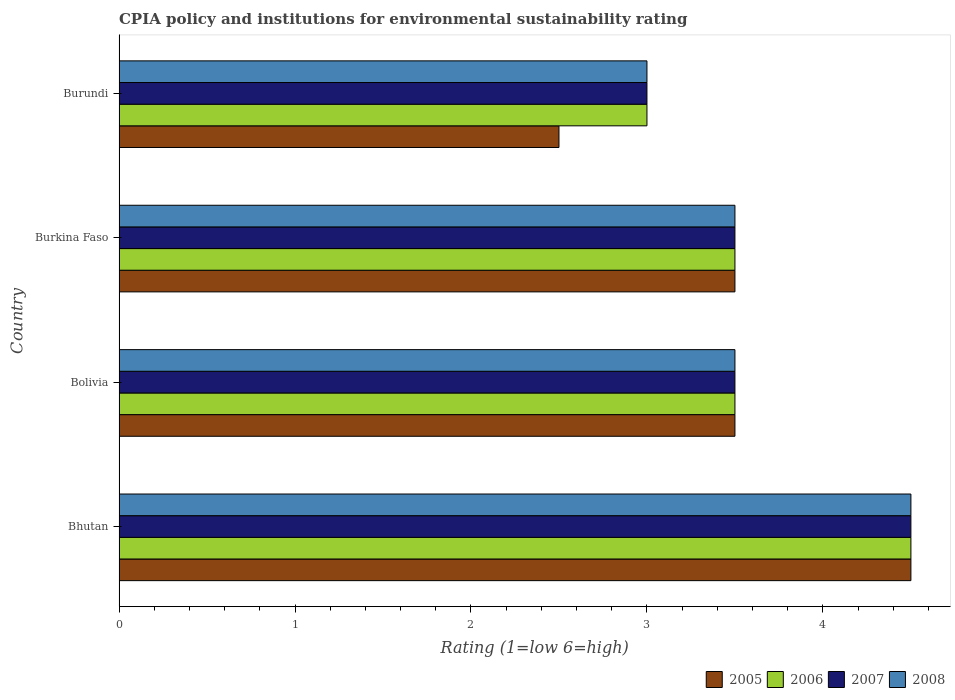How many different coloured bars are there?
Give a very brief answer. 4. How many groups of bars are there?
Your answer should be very brief. 4. How many bars are there on the 2nd tick from the bottom?
Provide a succinct answer. 4. In how many cases, is the number of bars for a given country not equal to the number of legend labels?
Offer a very short reply. 0. What is the CPIA rating in 2005 in Bolivia?
Make the answer very short. 3.5. Across all countries, what is the maximum CPIA rating in 2007?
Give a very brief answer. 4.5. Across all countries, what is the minimum CPIA rating in 2008?
Provide a succinct answer. 3. In which country was the CPIA rating in 2005 maximum?
Offer a very short reply. Bhutan. In which country was the CPIA rating in 2007 minimum?
Keep it short and to the point. Burundi. What is the total CPIA rating in 2008 in the graph?
Give a very brief answer. 14.5. What is the difference between the CPIA rating in 2005 in Bhutan and that in Burundi?
Keep it short and to the point. 2. What is the average CPIA rating in 2007 per country?
Offer a terse response. 3.62. In how many countries, is the CPIA rating in 2008 greater than 2.8 ?
Keep it short and to the point. 4. What is the ratio of the CPIA rating in 2006 in Bolivia to that in Burundi?
Keep it short and to the point. 1.17. Is the CPIA rating in 2005 in Bhutan less than that in Burkina Faso?
Make the answer very short. No. Is the difference between the CPIA rating in 2005 in Bhutan and Burundi greater than the difference between the CPIA rating in 2007 in Bhutan and Burundi?
Keep it short and to the point. Yes. What is the difference between the highest and the lowest CPIA rating in 2007?
Provide a succinct answer. 1.5. In how many countries, is the CPIA rating in 2008 greater than the average CPIA rating in 2008 taken over all countries?
Your answer should be compact. 1. Is it the case that in every country, the sum of the CPIA rating in 2005 and CPIA rating in 2008 is greater than the sum of CPIA rating in 2007 and CPIA rating in 2006?
Offer a terse response. No. How many bars are there?
Give a very brief answer. 16. What is the difference between two consecutive major ticks on the X-axis?
Ensure brevity in your answer.  1. Are the values on the major ticks of X-axis written in scientific E-notation?
Give a very brief answer. No. Does the graph contain any zero values?
Offer a terse response. No. How many legend labels are there?
Your answer should be very brief. 4. What is the title of the graph?
Keep it short and to the point. CPIA policy and institutions for environmental sustainability rating. What is the label or title of the X-axis?
Provide a succinct answer. Rating (1=low 6=high). What is the Rating (1=low 6=high) of 2005 in Bhutan?
Offer a very short reply. 4.5. What is the Rating (1=low 6=high) in 2006 in Bhutan?
Your answer should be compact. 4.5. What is the Rating (1=low 6=high) of 2007 in Bhutan?
Your answer should be compact. 4.5. What is the Rating (1=low 6=high) in 2005 in Bolivia?
Your answer should be compact. 3.5. What is the Rating (1=low 6=high) of 2006 in Bolivia?
Offer a very short reply. 3.5. What is the Rating (1=low 6=high) of 2007 in Bolivia?
Offer a very short reply. 3.5. What is the Rating (1=low 6=high) of 2006 in Burkina Faso?
Keep it short and to the point. 3.5. What is the Rating (1=low 6=high) in 2006 in Burundi?
Ensure brevity in your answer.  3. What is the Rating (1=low 6=high) in 2007 in Burundi?
Your response must be concise. 3. What is the Rating (1=low 6=high) in 2008 in Burundi?
Offer a terse response. 3. Across all countries, what is the maximum Rating (1=low 6=high) of 2007?
Your answer should be very brief. 4.5. Across all countries, what is the minimum Rating (1=low 6=high) in 2005?
Provide a succinct answer. 2.5. Across all countries, what is the minimum Rating (1=low 6=high) in 2006?
Your response must be concise. 3. What is the total Rating (1=low 6=high) of 2005 in the graph?
Keep it short and to the point. 14. What is the total Rating (1=low 6=high) in 2006 in the graph?
Ensure brevity in your answer.  14.5. What is the total Rating (1=low 6=high) of 2007 in the graph?
Give a very brief answer. 14.5. What is the total Rating (1=low 6=high) in 2008 in the graph?
Keep it short and to the point. 14.5. What is the difference between the Rating (1=low 6=high) of 2006 in Bhutan and that in Bolivia?
Keep it short and to the point. 1. What is the difference between the Rating (1=low 6=high) in 2007 in Bhutan and that in Bolivia?
Your answer should be very brief. 1. What is the difference between the Rating (1=low 6=high) in 2008 in Bhutan and that in Bolivia?
Your response must be concise. 1. What is the difference between the Rating (1=low 6=high) of 2005 in Bhutan and that in Burkina Faso?
Provide a short and direct response. 1. What is the difference between the Rating (1=low 6=high) of 2006 in Bhutan and that in Burkina Faso?
Keep it short and to the point. 1. What is the difference between the Rating (1=low 6=high) of 2008 in Bhutan and that in Burkina Faso?
Your answer should be very brief. 1. What is the difference between the Rating (1=low 6=high) of 2005 in Bolivia and that in Burkina Faso?
Provide a short and direct response. 0. What is the difference between the Rating (1=low 6=high) in 2008 in Bolivia and that in Burkina Faso?
Offer a very short reply. 0. What is the difference between the Rating (1=low 6=high) in 2005 in Bolivia and that in Burundi?
Ensure brevity in your answer.  1. What is the difference between the Rating (1=low 6=high) of 2007 in Bolivia and that in Burundi?
Keep it short and to the point. 0.5. What is the difference between the Rating (1=low 6=high) of 2008 in Burkina Faso and that in Burundi?
Keep it short and to the point. 0.5. What is the difference between the Rating (1=low 6=high) in 2005 in Bhutan and the Rating (1=low 6=high) in 2006 in Bolivia?
Your answer should be compact. 1. What is the difference between the Rating (1=low 6=high) in 2006 in Bhutan and the Rating (1=low 6=high) in 2007 in Bolivia?
Provide a succinct answer. 1. What is the difference between the Rating (1=low 6=high) of 2007 in Bhutan and the Rating (1=low 6=high) of 2008 in Bolivia?
Offer a very short reply. 1. What is the difference between the Rating (1=low 6=high) in 2005 in Bhutan and the Rating (1=low 6=high) in 2006 in Burkina Faso?
Your answer should be very brief. 1. What is the difference between the Rating (1=low 6=high) of 2005 in Bhutan and the Rating (1=low 6=high) of 2006 in Burundi?
Your response must be concise. 1.5. What is the difference between the Rating (1=low 6=high) in 2005 in Bhutan and the Rating (1=low 6=high) in 2007 in Burundi?
Ensure brevity in your answer.  1.5. What is the difference between the Rating (1=low 6=high) of 2006 in Bhutan and the Rating (1=low 6=high) of 2007 in Burundi?
Your answer should be very brief. 1.5. What is the difference between the Rating (1=low 6=high) in 2005 in Bolivia and the Rating (1=low 6=high) in 2006 in Burkina Faso?
Keep it short and to the point. 0. What is the difference between the Rating (1=low 6=high) in 2005 in Bolivia and the Rating (1=low 6=high) in 2008 in Burkina Faso?
Offer a very short reply. 0. What is the difference between the Rating (1=low 6=high) of 2006 in Bolivia and the Rating (1=low 6=high) of 2007 in Burkina Faso?
Provide a succinct answer. 0. What is the difference between the Rating (1=low 6=high) of 2006 in Bolivia and the Rating (1=low 6=high) of 2008 in Burkina Faso?
Your answer should be compact. 0. What is the difference between the Rating (1=low 6=high) in 2006 in Bolivia and the Rating (1=low 6=high) in 2008 in Burundi?
Make the answer very short. 0.5. What is the difference between the Rating (1=low 6=high) in 2005 in Burkina Faso and the Rating (1=low 6=high) in 2006 in Burundi?
Your response must be concise. 0.5. What is the difference between the Rating (1=low 6=high) of 2005 in Burkina Faso and the Rating (1=low 6=high) of 2007 in Burundi?
Provide a succinct answer. 0.5. What is the difference between the Rating (1=low 6=high) in 2006 in Burkina Faso and the Rating (1=low 6=high) in 2008 in Burundi?
Keep it short and to the point. 0.5. What is the average Rating (1=low 6=high) of 2006 per country?
Make the answer very short. 3.62. What is the average Rating (1=low 6=high) of 2007 per country?
Ensure brevity in your answer.  3.62. What is the average Rating (1=low 6=high) of 2008 per country?
Make the answer very short. 3.62. What is the difference between the Rating (1=low 6=high) in 2005 and Rating (1=low 6=high) in 2007 in Bhutan?
Ensure brevity in your answer.  0. What is the difference between the Rating (1=low 6=high) in 2006 and Rating (1=low 6=high) in 2007 in Bhutan?
Provide a short and direct response. 0. What is the difference between the Rating (1=low 6=high) in 2006 and Rating (1=low 6=high) in 2008 in Bhutan?
Offer a terse response. 0. What is the difference between the Rating (1=low 6=high) in 2007 and Rating (1=low 6=high) in 2008 in Bhutan?
Offer a terse response. 0. What is the difference between the Rating (1=low 6=high) of 2005 and Rating (1=low 6=high) of 2006 in Bolivia?
Keep it short and to the point. 0. What is the difference between the Rating (1=low 6=high) of 2005 and Rating (1=low 6=high) of 2007 in Bolivia?
Your response must be concise. 0. What is the difference between the Rating (1=low 6=high) of 2006 and Rating (1=low 6=high) of 2007 in Bolivia?
Provide a short and direct response. 0. What is the difference between the Rating (1=low 6=high) of 2007 and Rating (1=low 6=high) of 2008 in Bolivia?
Offer a terse response. 0. What is the difference between the Rating (1=low 6=high) of 2005 and Rating (1=low 6=high) of 2007 in Burkina Faso?
Ensure brevity in your answer.  0. What is the difference between the Rating (1=low 6=high) in 2005 and Rating (1=low 6=high) in 2008 in Burkina Faso?
Your response must be concise. 0. What is the difference between the Rating (1=low 6=high) in 2006 and Rating (1=low 6=high) in 2007 in Burkina Faso?
Your response must be concise. 0. What is the difference between the Rating (1=low 6=high) of 2006 and Rating (1=low 6=high) of 2007 in Burundi?
Offer a terse response. 0. What is the difference between the Rating (1=low 6=high) of 2007 and Rating (1=low 6=high) of 2008 in Burundi?
Your answer should be very brief. 0. What is the ratio of the Rating (1=low 6=high) in 2005 in Bhutan to that in Bolivia?
Make the answer very short. 1.29. What is the ratio of the Rating (1=low 6=high) of 2006 in Bhutan to that in Bolivia?
Your answer should be compact. 1.29. What is the ratio of the Rating (1=low 6=high) of 2005 in Bhutan to that in Burkina Faso?
Keep it short and to the point. 1.29. What is the ratio of the Rating (1=low 6=high) in 2006 in Bhutan to that in Burkina Faso?
Your response must be concise. 1.29. What is the ratio of the Rating (1=low 6=high) in 2007 in Bhutan to that in Burkina Faso?
Offer a very short reply. 1.29. What is the ratio of the Rating (1=low 6=high) of 2005 in Bhutan to that in Burundi?
Your response must be concise. 1.8. What is the ratio of the Rating (1=low 6=high) in 2007 in Bolivia to that in Burkina Faso?
Your answer should be very brief. 1. What is the ratio of the Rating (1=low 6=high) of 2005 in Bolivia to that in Burundi?
Your response must be concise. 1.4. What is the ratio of the Rating (1=low 6=high) of 2006 in Bolivia to that in Burundi?
Offer a very short reply. 1.17. What is the ratio of the Rating (1=low 6=high) of 2007 in Bolivia to that in Burundi?
Provide a short and direct response. 1.17. What is the ratio of the Rating (1=low 6=high) in 2005 in Burkina Faso to that in Burundi?
Offer a terse response. 1.4. What is the ratio of the Rating (1=low 6=high) in 2007 in Burkina Faso to that in Burundi?
Keep it short and to the point. 1.17. What is the difference between the highest and the second highest Rating (1=low 6=high) of 2006?
Ensure brevity in your answer.  1. What is the difference between the highest and the second highest Rating (1=low 6=high) of 2008?
Offer a very short reply. 1. What is the difference between the highest and the lowest Rating (1=low 6=high) in 2005?
Ensure brevity in your answer.  2. What is the difference between the highest and the lowest Rating (1=low 6=high) in 2006?
Offer a very short reply. 1.5. 